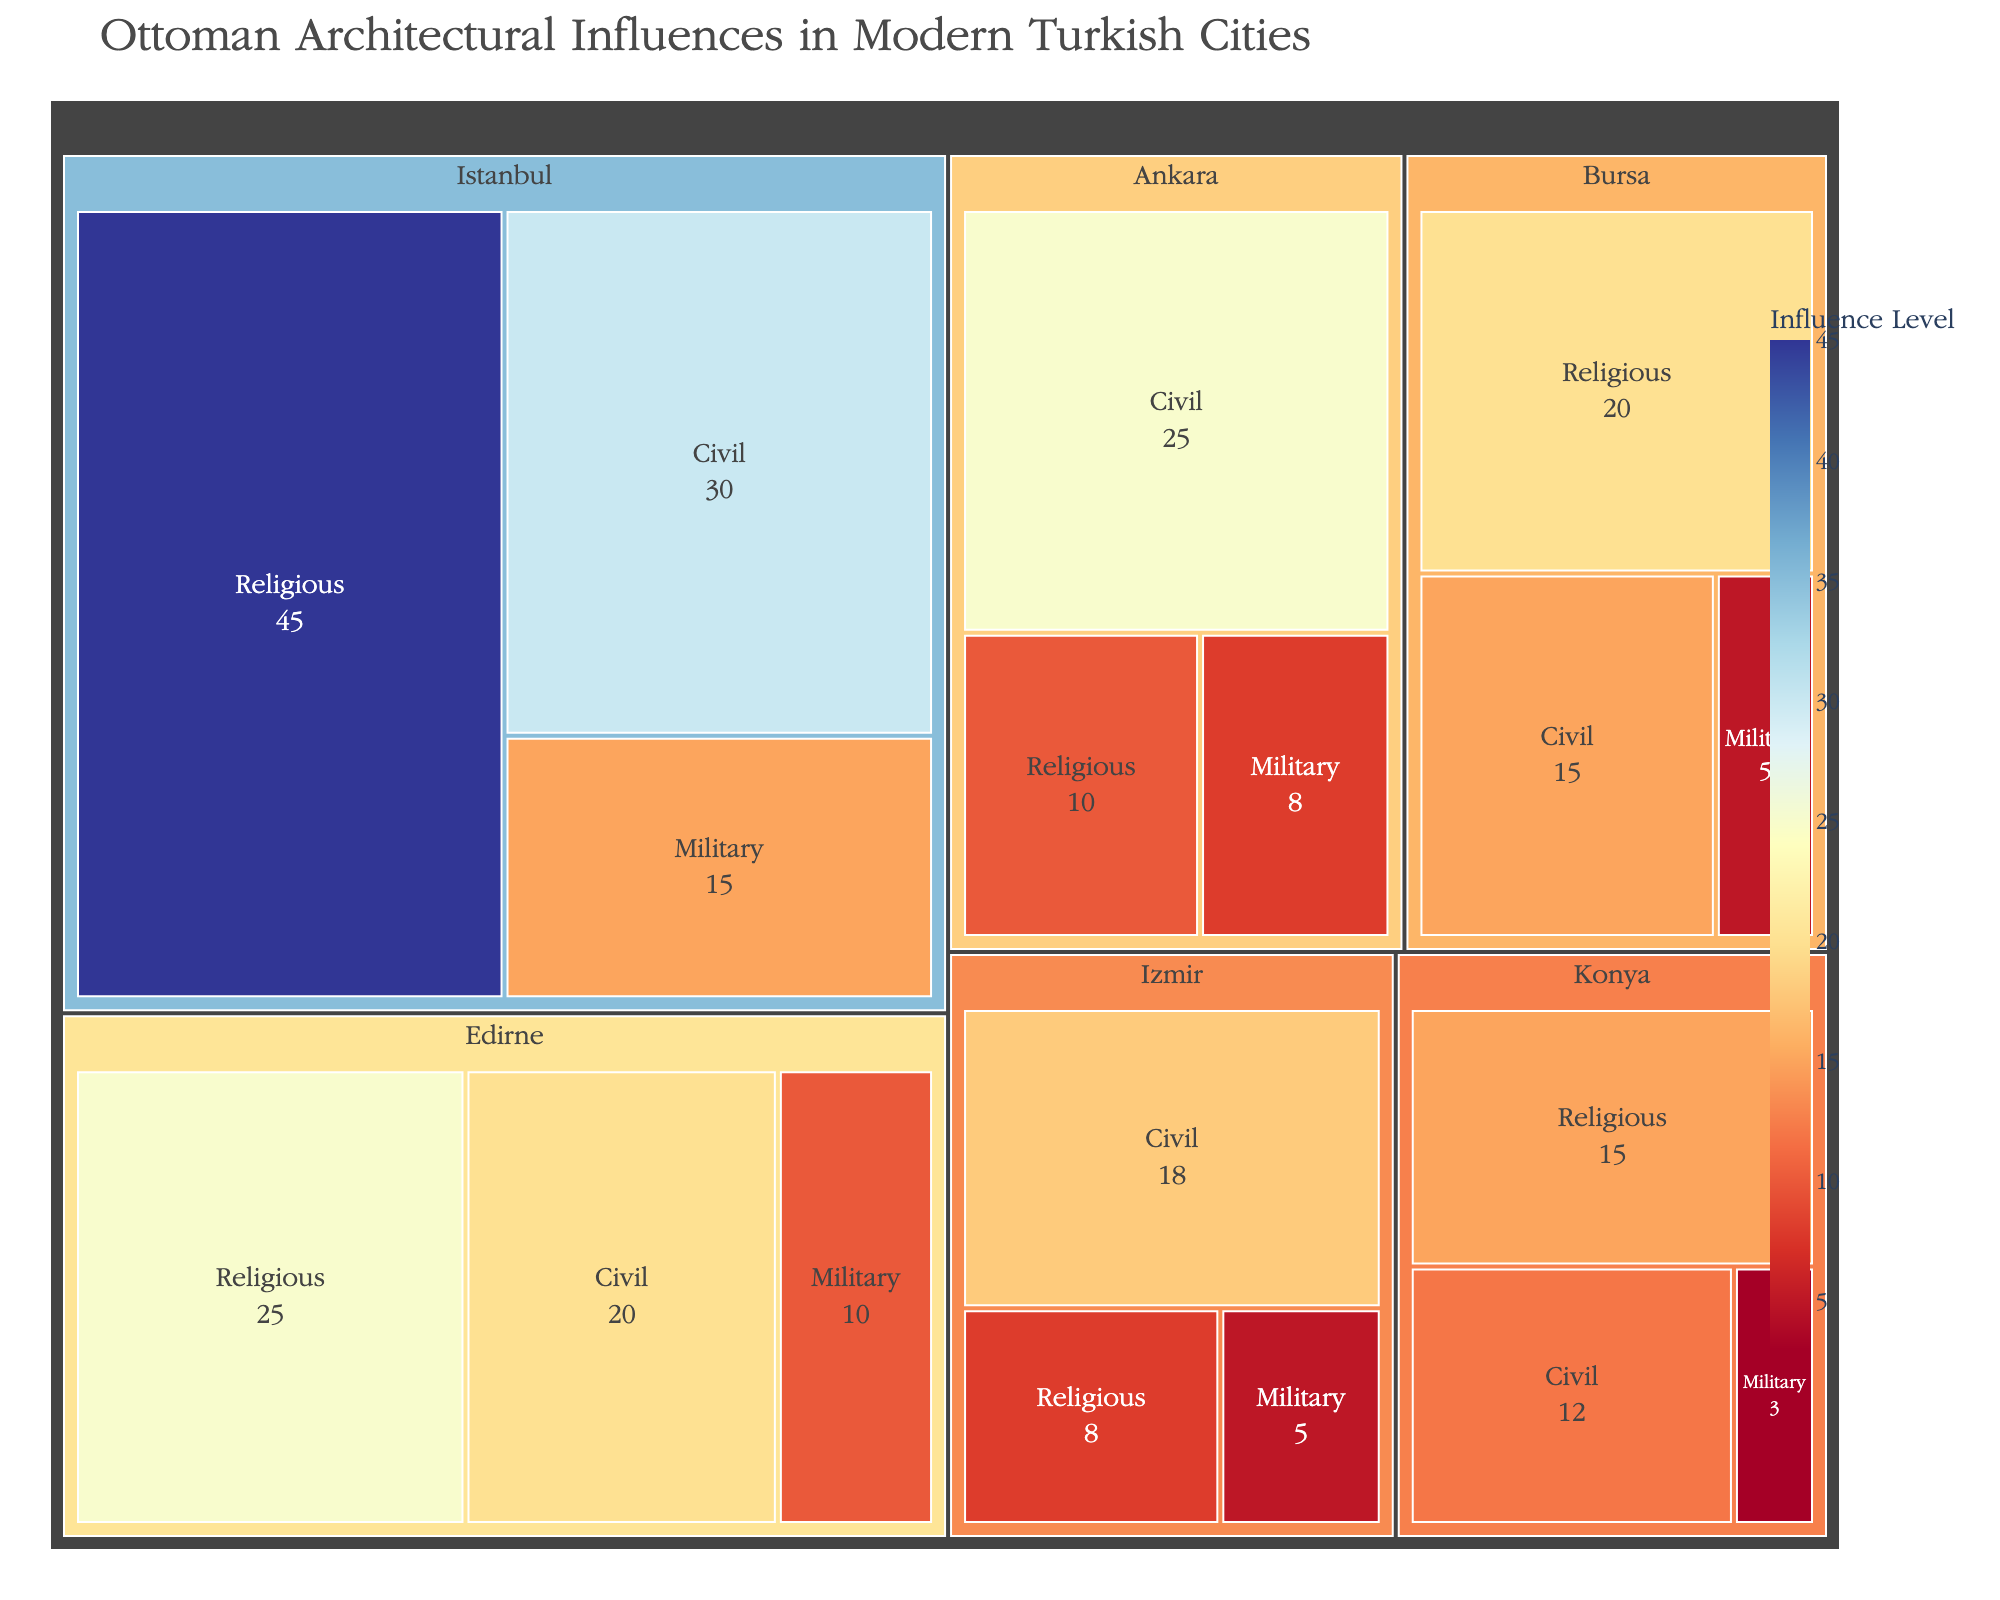What's the dominant architectural influence category in Istanbul? Based on the Treemap, we observe that the largest area for Istanbul corresponds to the Religious category with an influence of 45. This is the highest value among all categories in Istanbul.
Answer: Religious Which city has the highest influence in the Civil category? By examining the Treemap, we see that among all the cities, Istanbul has the highest influence in the Civil category with a value of 30.
Answer: Istanbul How many cities have a Military influence greater than 5? From the Treemap, we identify the cities and their corresponding Military influences: Istanbul (15), Edirne (10), Ankara (8), Bursa (5), Izmir (5), Konya (3). Only Istanbul, Edirne, and Ankara have Military influences greater than 5.
Answer: 3 What's the combined influence of Religious and Civil categories in Edirne? To find the combined influence, add the Religious influence (25) and the Civil influence (20) in Edirne. This results in a total influence of 45 for both categories.
Answer: 45 Which city has the smallest overall architectural influence across all categories? To determine this, sum the influences for each city across all categories and compare: Istanbul (90), Edirne (55), Bursa (40), Ankara (43), Izmir (31), Konya (30). Konya, with a total influence of 30, has the smallest overall architectural influence.
Answer: Konya Compare the Religious influence in Istanbul and Izmir. Which city has a higher influence and by how much? The Religious influence values for Istanbul and Izmir are 45 and 8, respectively. To find the difference, calculate 45 - 8, resulting in a difference of 37.
Answer: Istanbul by 37 What's the average influence of the Military category across all cities? To calculate the average, sum the Military influences for all cities: 15 (Istanbul) + 10 (Edirne) + 5 (Bursa) + 8 (Ankara) + 5 (Izmir) + 3 (Konya) = 46. Divide this total by the number of cities (6), resulting in an average influence of 7.67.
Answer: 7.67 Which city has the most equal distribution of influence among the three categories? To find the most equal distribution, look for the city where the differences between categories are smallest. Comparing the differences in influence values for each city, Konya has the closest values with Religious (15), Civil (12), and Military (3), showing relatively minimal disparity.
Answer: Konya What is the proportion of Civil influence in Ankara compared to its total influence? First, sum Ankara’s total influence: 10 (Religious) + 25 (Civil) + 8 (Military) = 43. The proportion of Civil influence is then 25 / 43, which approximately equals 0.581 (or 58.1%).
Answer: 58.1% 